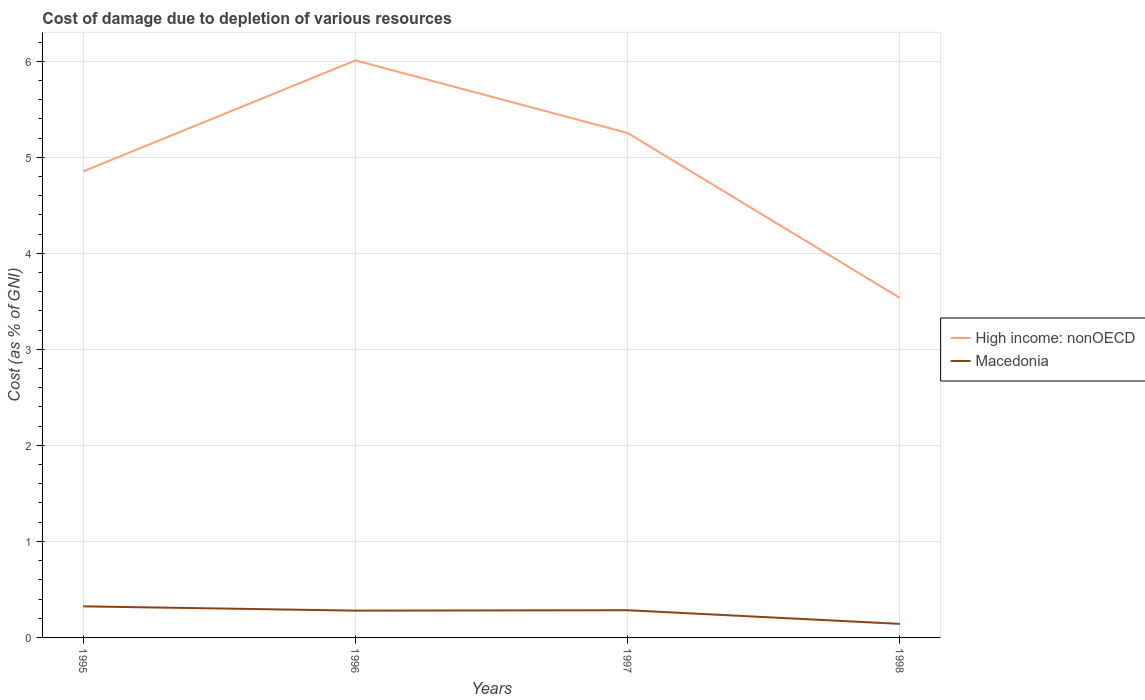Across all years, what is the maximum cost of damage caused due to the depletion of various resources in Macedonia?
Keep it short and to the point. 0.14. What is the total cost of damage caused due to the depletion of various resources in High income: nonOECD in the graph?
Keep it short and to the point. -1.16. What is the difference between the highest and the second highest cost of damage caused due to the depletion of various resources in High income: nonOECD?
Keep it short and to the point. 2.47. Are the values on the major ticks of Y-axis written in scientific E-notation?
Keep it short and to the point. No. Does the graph contain grids?
Your response must be concise. Yes. What is the title of the graph?
Offer a very short reply. Cost of damage due to depletion of various resources. Does "World" appear as one of the legend labels in the graph?
Your response must be concise. No. What is the label or title of the Y-axis?
Your response must be concise. Cost (as % of GNI). What is the Cost (as % of GNI) of High income: nonOECD in 1995?
Provide a succinct answer. 4.85. What is the Cost (as % of GNI) in Macedonia in 1995?
Keep it short and to the point. 0.32. What is the Cost (as % of GNI) of High income: nonOECD in 1996?
Provide a short and direct response. 6.01. What is the Cost (as % of GNI) in Macedonia in 1996?
Give a very brief answer. 0.28. What is the Cost (as % of GNI) in High income: nonOECD in 1997?
Give a very brief answer. 5.25. What is the Cost (as % of GNI) in Macedonia in 1997?
Keep it short and to the point. 0.28. What is the Cost (as % of GNI) of High income: nonOECD in 1998?
Keep it short and to the point. 3.54. What is the Cost (as % of GNI) in Macedonia in 1998?
Offer a terse response. 0.14. Across all years, what is the maximum Cost (as % of GNI) of High income: nonOECD?
Your response must be concise. 6.01. Across all years, what is the maximum Cost (as % of GNI) in Macedonia?
Your response must be concise. 0.32. Across all years, what is the minimum Cost (as % of GNI) of High income: nonOECD?
Ensure brevity in your answer.  3.54. Across all years, what is the minimum Cost (as % of GNI) of Macedonia?
Your answer should be compact. 0.14. What is the total Cost (as % of GNI) of High income: nonOECD in the graph?
Your answer should be compact. 19.65. What is the total Cost (as % of GNI) in Macedonia in the graph?
Make the answer very short. 1.03. What is the difference between the Cost (as % of GNI) of High income: nonOECD in 1995 and that in 1996?
Give a very brief answer. -1.16. What is the difference between the Cost (as % of GNI) in Macedonia in 1995 and that in 1996?
Offer a very short reply. 0.04. What is the difference between the Cost (as % of GNI) in High income: nonOECD in 1995 and that in 1997?
Make the answer very short. -0.4. What is the difference between the Cost (as % of GNI) of Macedonia in 1995 and that in 1997?
Your answer should be very brief. 0.04. What is the difference between the Cost (as % of GNI) of High income: nonOECD in 1995 and that in 1998?
Offer a terse response. 1.32. What is the difference between the Cost (as % of GNI) of Macedonia in 1995 and that in 1998?
Your answer should be very brief. 0.18. What is the difference between the Cost (as % of GNI) of High income: nonOECD in 1996 and that in 1997?
Give a very brief answer. 0.76. What is the difference between the Cost (as % of GNI) of Macedonia in 1996 and that in 1997?
Ensure brevity in your answer.  -0. What is the difference between the Cost (as % of GNI) of High income: nonOECD in 1996 and that in 1998?
Provide a short and direct response. 2.47. What is the difference between the Cost (as % of GNI) of Macedonia in 1996 and that in 1998?
Ensure brevity in your answer.  0.14. What is the difference between the Cost (as % of GNI) of High income: nonOECD in 1997 and that in 1998?
Offer a terse response. 1.72. What is the difference between the Cost (as % of GNI) of Macedonia in 1997 and that in 1998?
Provide a short and direct response. 0.14. What is the difference between the Cost (as % of GNI) of High income: nonOECD in 1995 and the Cost (as % of GNI) of Macedonia in 1996?
Your response must be concise. 4.57. What is the difference between the Cost (as % of GNI) of High income: nonOECD in 1995 and the Cost (as % of GNI) of Macedonia in 1997?
Keep it short and to the point. 4.57. What is the difference between the Cost (as % of GNI) in High income: nonOECD in 1995 and the Cost (as % of GNI) in Macedonia in 1998?
Your answer should be very brief. 4.71. What is the difference between the Cost (as % of GNI) of High income: nonOECD in 1996 and the Cost (as % of GNI) of Macedonia in 1997?
Keep it short and to the point. 5.73. What is the difference between the Cost (as % of GNI) in High income: nonOECD in 1996 and the Cost (as % of GNI) in Macedonia in 1998?
Your answer should be very brief. 5.87. What is the difference between the Cost (as % of GNI) in High income: nonOECD in 1997 and the Cost (as % of GNI) in Macedonia in 1998?
Provide a succinct answer. 5.11. What is the average Cost (as % of GNI) of High income: nonOECD per year?
Provide a succinct answer. 4.91. What is the average Cost (as % of GNI) in Macedonia per year?
Provide a succinct answer. 0.26. In the year 1995, what is the difference between the Cost (as % of GNI) of High income: nonOECD and Cost (as % of GNI) of Macedonia?
Ensure brevity in your answer.  4.53. In the year 1996, what is the difference between the Cost (as % of GNI) in High income: nonOECD and Cost (as % of GNI) in Macedonia?
Provide a succinct answer. 5.73. In the year 1997, what is the difference between the Cost (as % of GNI) of High income: nonOECD and Cost (as % of GNI) of Macedonia?
Your answer should be compact. 4.97. In the year 1998, what is the difference between the Cost (as % of GNI) of High income: nonOECD and Cost (as % of GNI) of Macedonia?
Ensure brevity in your answer.  3.4. What is the ratio of the Cost (as % of GNI) in High income: nonOECD in 1995 to that in 1996?
Make the answer very short. 0.81. What is the ratio of the Cost (as % of GNI) of Macedonia in 1995 to that in 1996?
Ensure brevity in your answer.  1.16. What is the ratio of the Cost (as % of GNI) of High income: nonOECD in 1995 to that in 1997?
Give a very brief answer. 0.92. What is the ratio of the Cost (as % of GNI) of Macedonia in 1995 to that in 1997?
Ensure brevity in your answer.  1.14. What is the ratio of the Cost (as % of GNI) of High income: nonOECD in 1995 to that in 1998?
Make the answer very short. 1.37. What is the ratio of the Cost (as % of GNI) in Macedonia in 1995 to that in 1998?
Provide a short and direct response. 2.29. What is the ratio of the Cost (as % of GNI) of High income: nonOECD in 1996 to that in 1997?
Your answer should be very brief. 1.14. What is the ratio of the Cost (as % of GNI) in Macedonia in 1996 to that in 1997?
Provide a short and direct response. 0.99. What is the ratio of the Cost (as % of GNI) of High income: nonOECD in 1996 to that in 1998?
Provide a short and direct response. 1.7. What is the ratio of the Cost (as % of GNI) in Macedonia in 1996 to that in 1998?
Keep it short and to the point. 1.98. What is the ratio of the Cost (as % of GNI) of High income: nonOECD in 1997 to that in 1998?
Provide a succinct answer. 1.49. What is the ratio of the Cost (as % of GNI) in Macedonia in 1997 to that in 1998?
Your response must be concise. 2.01. What is the difference between the highest and the second highest Cost (as % of GNI) in High income: nonOECD?
Ensure brevity in your answer.  0.76. What is the difference between the highest and the second highest Cost (as % of GNI) of Macedonia?
Provide a succinct answer. 0.04. What is the difference between the highest and the lowest Cost (as % of GNI) of High income: nonOECD?
Ensure brevity in your answer.  2.47. What is the difference between the highest and the lowest Cost (as % of GNI) of Macedonia?
Offer a terse response. 0.18. 